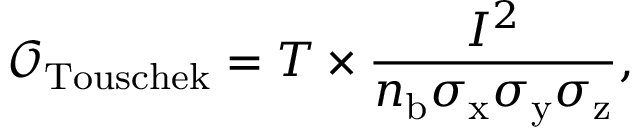<formula> <loc_0><loc_0><loc_500><loc_500>\mathcal { O } _ { T o u s c h e k } = T \times \frac { I ^ { 2 } } { n _ { b } \sigma _ { x } \sigma _ { y } \sigma _ { z } } ,</formula> 